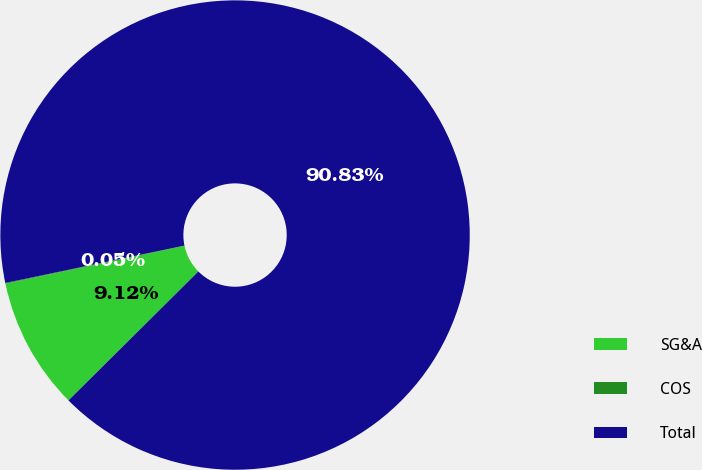Convert chart to OTSL. <chart><loc_0><loc_0><loc_500><loc_500><pie_chart><fcel>SG&A<fcel>COS<fcel>Total<nl><fcel>9.12%<fcel>0.05%<fcel>90.83%<nl></chart> 